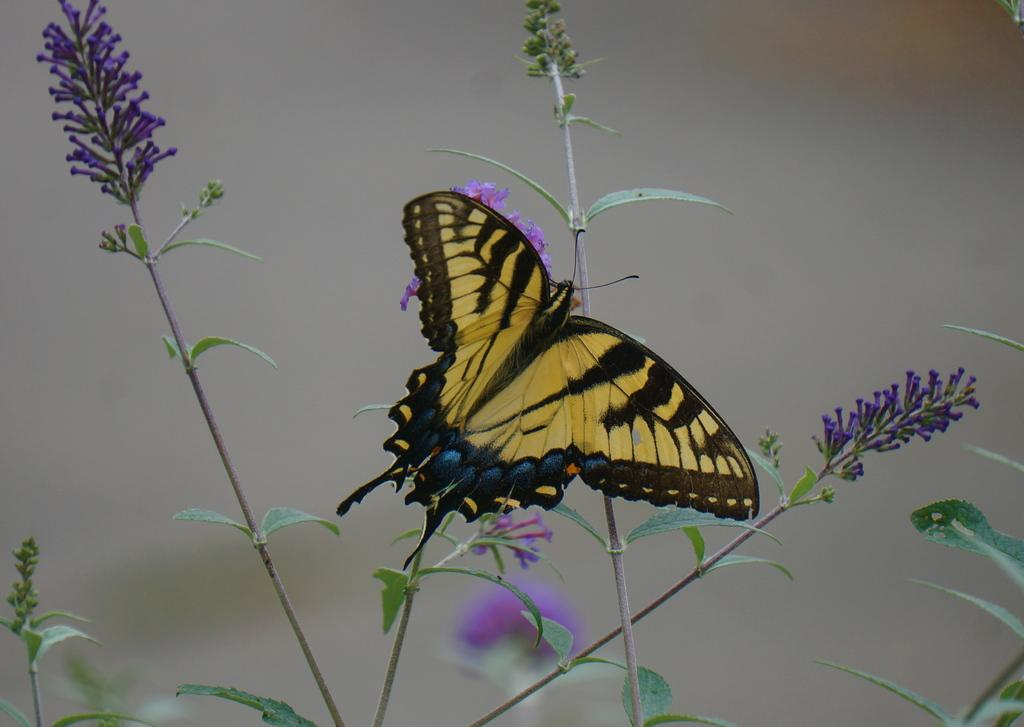What is the main subject of the image? The main subject of the image is a butterfly. Where is the butterfly located in relation to the plants? The butterfly is on plants in the image. In which part of the image is the butterfly situated? The butterfly is in the foreground of the image. What type of queen can be seen visiting the butterfly at the zoo in the image? There is no queen or zoo present in the image; it features a butterfly on plants. Can you describe the arch that the butterfly is flying under in the image? There is no arch present in the image; the butterfly is on plants. 